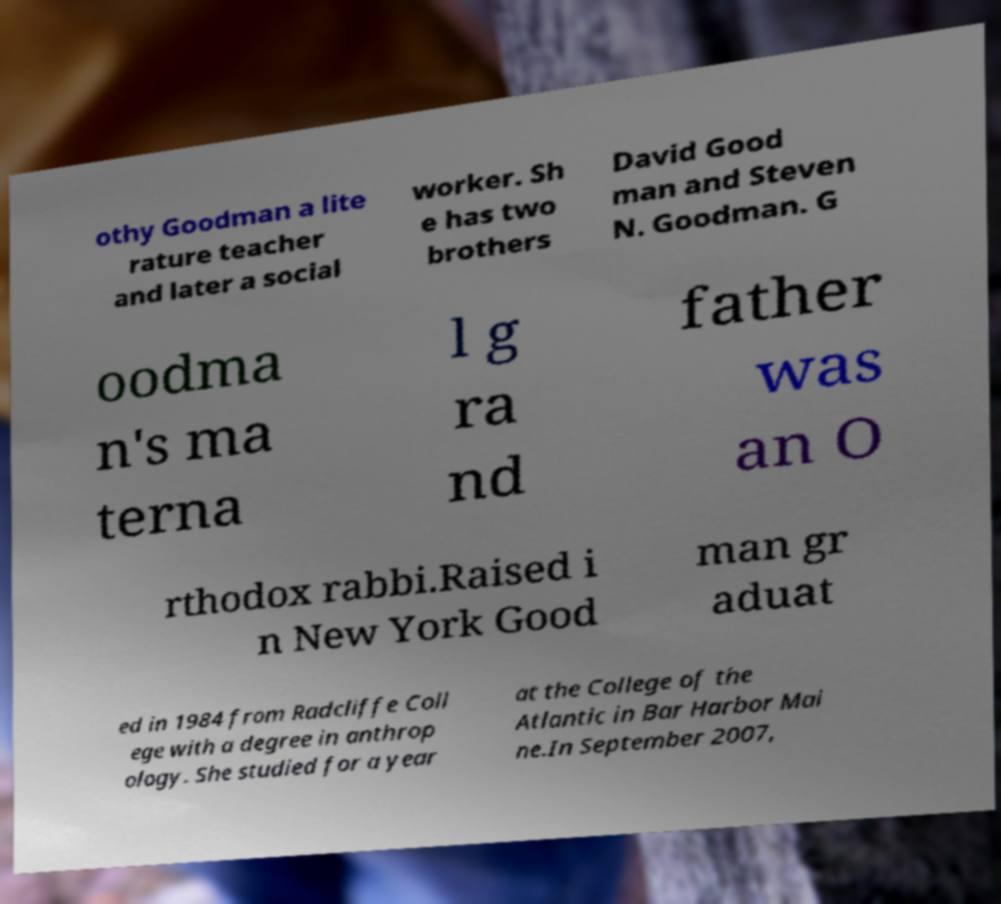I need the written content from this picture converted into text. Can you do that? othy Goodman a lite rature teacher and later a social worker. Sh e has two brothers David Good man and Steven N. Goodman. G oodma n's ma terna l g ra nd father was an O rthodox rabbi.Raised i n New York Good man gr aduat ed in 1984 from Radcliffe Coll ege with a degree in anthrop ology. She studied for a year at the College of the Atlantic in Bar Harbor Mai ne.In September 2007, 